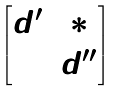Convert formula to latex. <formula><loc_0><loc_0><loc_500><loc_500>\begin{bmatrix} d ^ { \prime } & * \\ 0 & d ^ { \prime \prime } \end{bmatrix}</formula> 